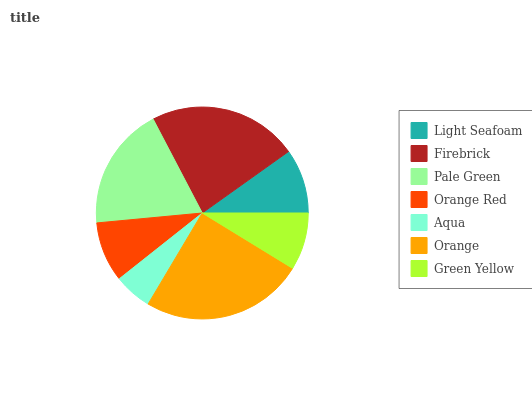Is Aqua the minimum?
Answer yes or no. Yes. Is Orange the maximum?
Answer yes or no. Yes. Is Firebrick the minimum?
Answer yes or no. No. Is Firebrick the maximum?
Answer yes or no. No. Is Firebrick greater than Light Seafoam?
Answer yes or no. Yes. Is Light Seafoam less than Firebrick?
Answer yes or no. Yes. Is Light Seafoam greater than Firebrick?
Answer yes or no. No. Is Firebrick less than Light Seafoam?
Answer yes or no. No. Is Light Seafoam the high median?
Answer yes or no. Yes. Is Light Seafoam the low median?
Answer yes or no. Yes. Is Orange Red the high median?
Answer yes or no. No. Is Pale Green the low median?
Answer yes or no. No. 